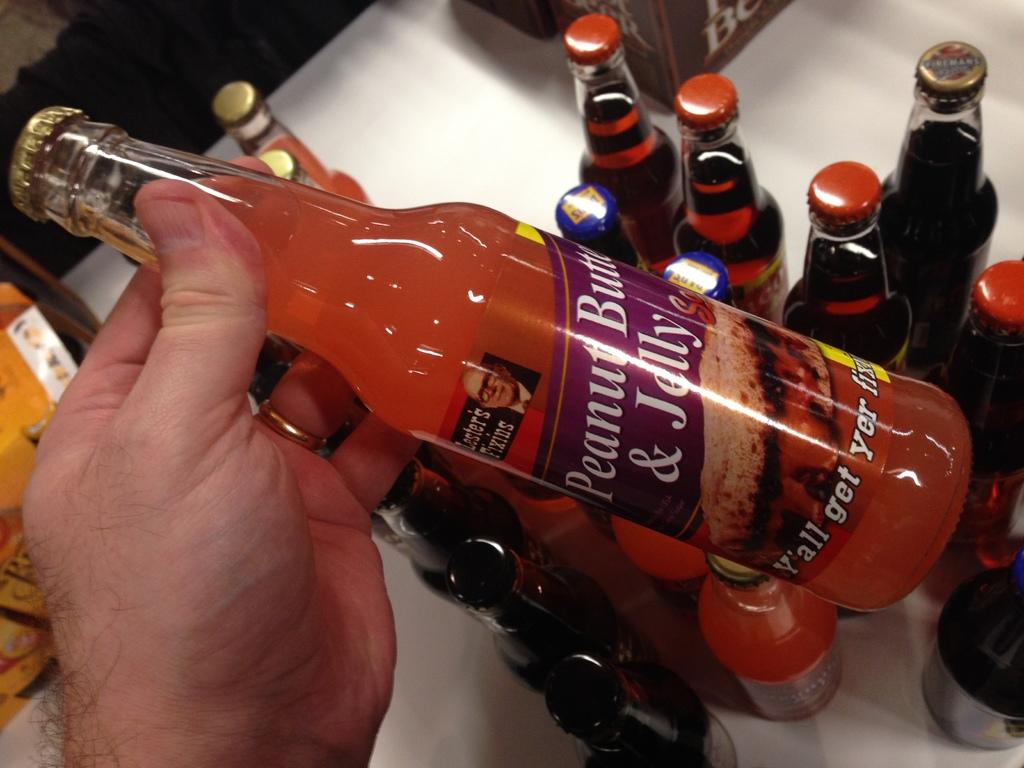<image>
Share a concise interpretation of the image provided. Person holding an orange bottle of Peanut Butter & Jelly. 